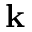<formula> <loc_0><loc_0><loc_500><loc_500>{ k }</formula> 